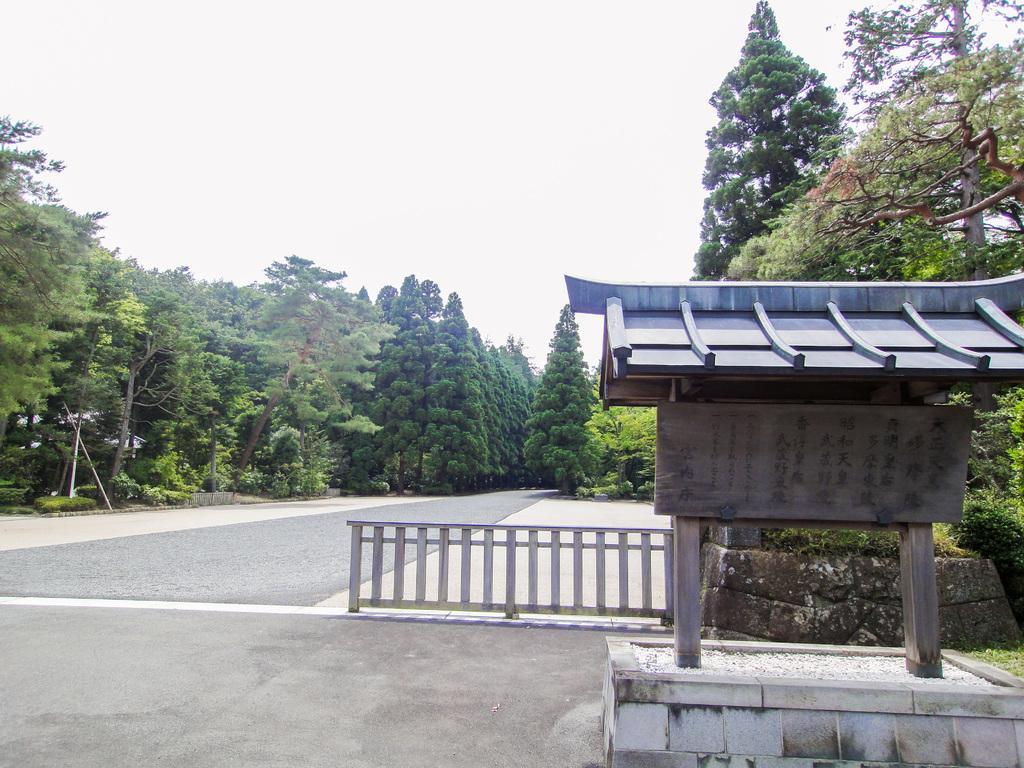How would you summarize this image in a sentence or two? On the right side of the image there is a wooden structure. At the center of the image there is a road and we can see a metal fence. In the background of the image there are trees and sky. 